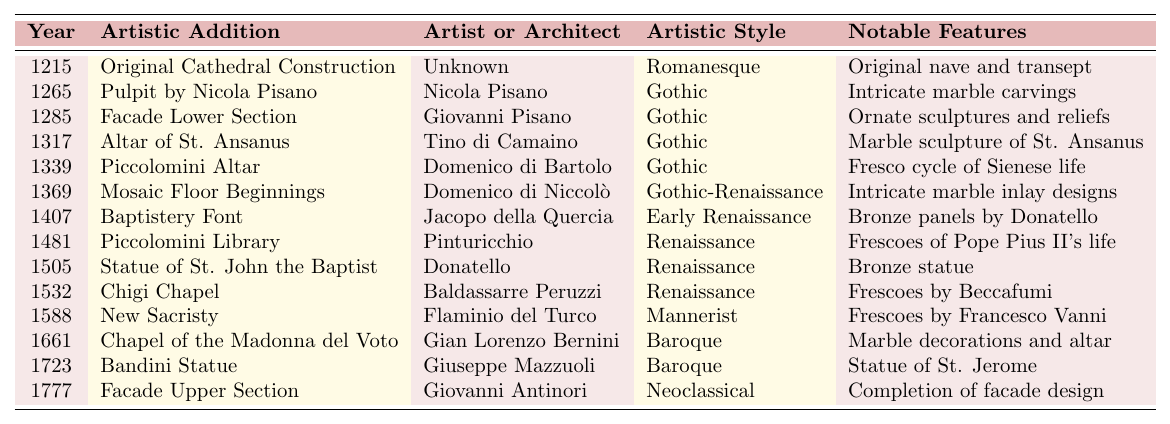What is the artistic addition made in 1215? The table indicates that the artistic addition in the year 1215 is the "Original Cathedral Construction."
Answer: Original Cathedral Construction Who created the pulpit in 1265? According to the table, the pulpit made in 1265 was created by Nicola Pisano.
Answer: Nicola Pisano What artistic style is associated with the Piccolomini Library added in 1481? The table indicates that the Piccolomini Library, added in 1481, is associated with the Renaissance artistic style.
Answer: Renaissance How many artistic additions were made in the Gothic style? The table lists five artistic additions in the Gothic style: the pulpit (1265), facade lower section (1285), altar of St. Ansanus (1317), Piccolomini altar (1339), and the beginnings of the mosaic floor (1369). Therefore, the total is 5.
Answer: 5 Is the Bandini Statue a Baroque work? The table states that the Bandini Statue, added in 1723, was created by Giuseppe Mazzuoli, indicating it is classified as Baroque.
Answer: Yes Which artistic addition involved frescoes by Pinturicchio? The table notes that the Piccolomini Library, added in 1481 and designed by Pinturicchio, involved frescoes.
Answer: Piccolomini Library What notable feature is associated with the new sacristy completed in 1588? The table specifies that the new sacristy, completed in 1588, is associated with frescoes by Francesco Vanni as a notable feature.
Answer: Frescoes by Francesco Vanni Which year marked the construction of the Baptistery Font? The table shows that the Baptistery Font was constructed in the year 1407.
Answer: 1407 What is the artistic style of the Facade Upper Section? The table indicates that the Facade Upper Section, completed in 1777, is classified as Neoclassical in artistic style.
Answer: Neoclassical Which artist designed the Chigi Chapel? According to the table, the Chigi Chapel was designed by Baldassarre Peruzzi.
Answer: Baldassarre Peruzzi Count the number of additions made between 1500 and 1700. The table shows four additions made during this time: Statue of St. John the Baptist (1505), Chigi Chapel (1532), New Sacristy (1588), and Chapel of the Madonna del Voto (1661), so the total is 4.
Answer: 4 